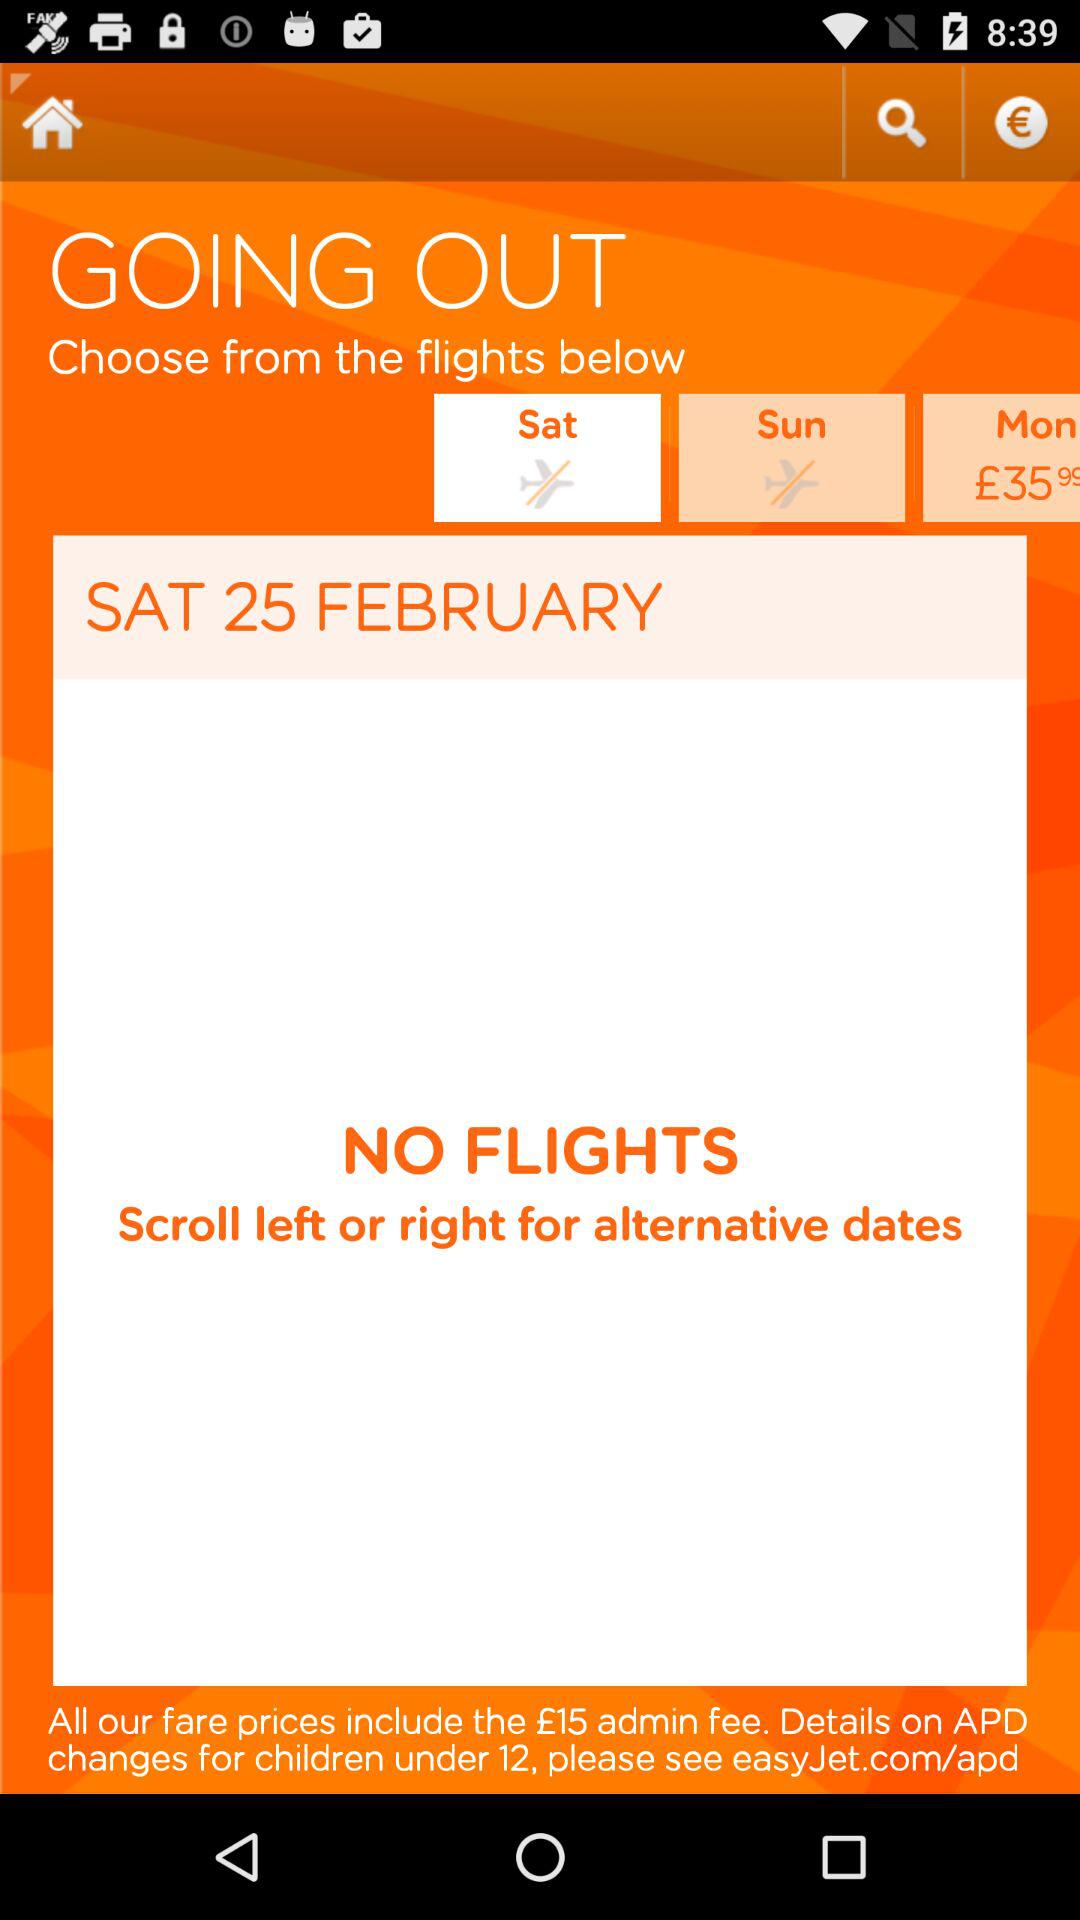Which day is selected for travelling? The selected day is Saturday. 